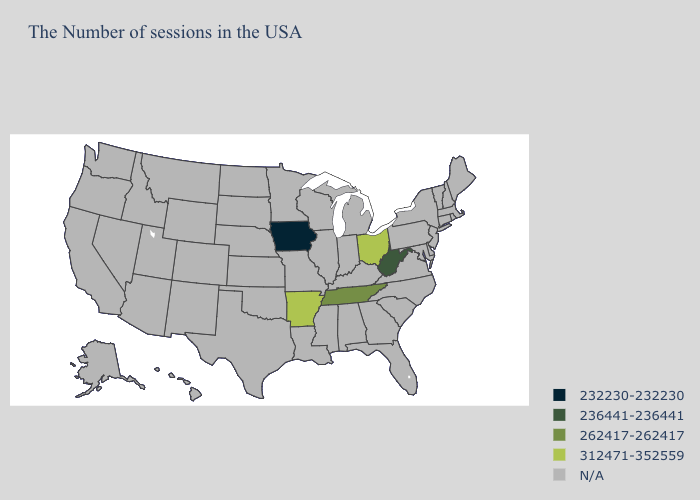What is the value of Montana?
Write a very short answer. N/A. Name the states that have a value in the range 262417-262417?
Give a very brief answer. Tennessee. Name the states that have a value in the range 236441-236441?
Write a very short answer. West Virginia. What is the value of Minnesota?
Short answer required. N/A. Name the states that have a value in the range N/A?
Keep it brief. Maine, Massachusetts, Rhode Island, New Hampshire, Vermont, Connecticut, New York, New Jersey, Delaware, Maryland, Pennsylvania, Virginia, North Carolina, South Carolina, Florida, Georgia, Michigan, Kentucky, Indiana, Alabama, Wisconsin, Illinois, Mississippi, Louisiana, Missouri, Minnesota, Kansas, Nebraska, Oklahoma, Texas, South Dakota, North Dakota, Wyoming, Colorado, New Mexico, Utah, Montana, Arizona, Idaho, Nevada, California, Washington, Oregon, Alaska, Hawaii. What is the value of Maine?
Answer briefly. N/A. What is the value of Nebraska?
Short answer required. N/A. What is the highest value in the USA?
Write a very short answer. 312471-352559. What is the highest value in the South ?
Concise answer only. 312471-352559. What is the value of Kentucky?
Be succinct. N/A. Does West Virginia have the highest value in the USA?
Answer briefly. No. 